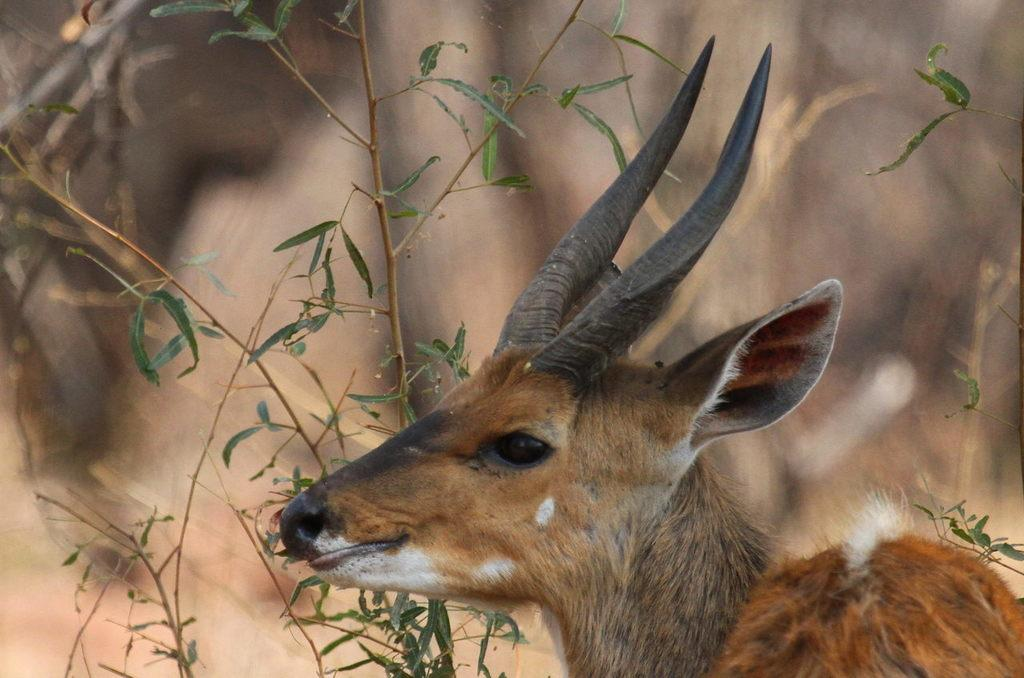What animal is present in the image? There is a deer in the image. What other living organism can be seen in the image? There is a plant in the image. How would you describe the background of the image? The background of the image is blurred. What type of cover is being used to protect the seashore in the image? There is no mention of a seashore or any type of cover in the image; it features a deer and a plant with a blurred background. 